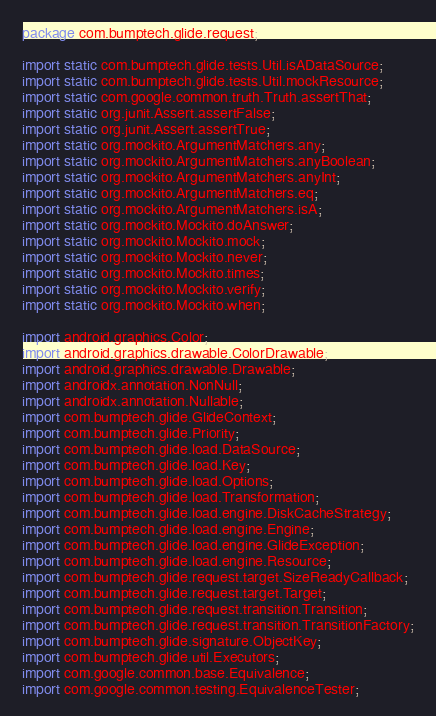Convert code to text. <code><loc_0><loc_0><loc_500><loc_500><_Java_>package com.bumptech.glide.request;

import static com.bumptech.glide.tests.Util.isADataSource;
import static com.bumptech.glide.tests.Util.mockResource;
import static com.google.common.truth.Truth.assertThat;
import static org.junit.Assert.assertFalse;
import static org.junit.Assert.assertTrue;
import static org.mockito.ArgumentMatchers.any;
import static org.mockito.ArgumentMatchers.anyBoolean;
import static org.mockito.ArgumentMatchers.anyInt;
import static org.mockito.ArgumentMatchers.eq;
import static org.mockito.ArgumentMatchers.isA;
import static org.mockito.Mockito.doAnswer;
import static org.mockito.Mockito.mock;
import static org.mockito.Mockito.never;
import static org.mockito.Mockito.times;
import static org.mockito.Mockito.verify;
import static org.mockito.Mockito.when;

import android.graphics.Color;
import android.graphics.drawable.ColorDrawable;
import android.graphics.drawable.Drawable;
import androidx.annotation.NonNull;
import androidx.annotation.Nullable;
import com.bumptech.glide.GlideContext;
import com.bumptech.glide.Priority;
import com.bumptech.glide.load.DataSource;
import com.bumptech.glide.load.Key;
import com.bumptech.glide.load.Options;
import com.bumptech.glide.load.Transformation;
import com.bumptech.glide.load.engine.DiskCacheStrategy;
import com.bumptech.glide.load.engine.Engine;
import com.bumptech.glide.load.engine.GlideException;
import com.bumptech.glide.load.engine.Resource;
import com.bumptech.glide.request.target.SizeReadyCallback;
import com.bumptech.glide.request.target.Target;
import com.bumptech.glide.request.transition.Transition;
import com.bumptech.glide.request.transition.TransitionFactory;
import com.bumptech.glide.signature.ObjectKey;
import com.bumptech.glide.util.Executors;
import com.google.common.base.Equivalence;
import com.google.common.testing.EquivalenceTester;</code> 